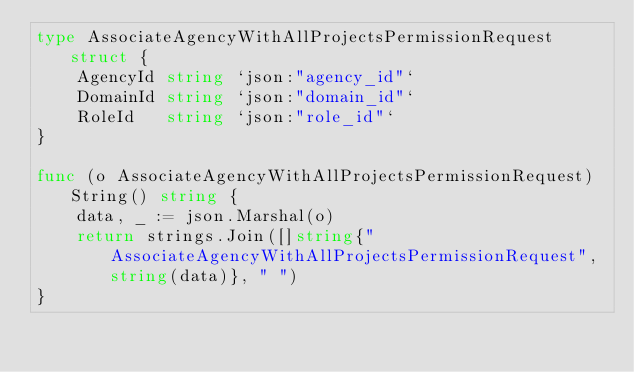Convert code to text. <code><loc_0><loc_0><loc_500><loc_500><_Go_>type AssociateAgencyWithAllProjectsPermissionRequest struct {
	AgencyId string `json:"agency_id"`
	DomainId string `json:"domain_id"`
	RoleId   string `json:"role_id"`
}

func (o AssociateAgencyWithAllProjectsPermissionRequest) String() string {
	data, _ := json.Marshal(o)
	return strings.Join([]string{"AssociateAgencyWithAllProjectsPermissionRequest", string(data)}, " ")
}
</code> 